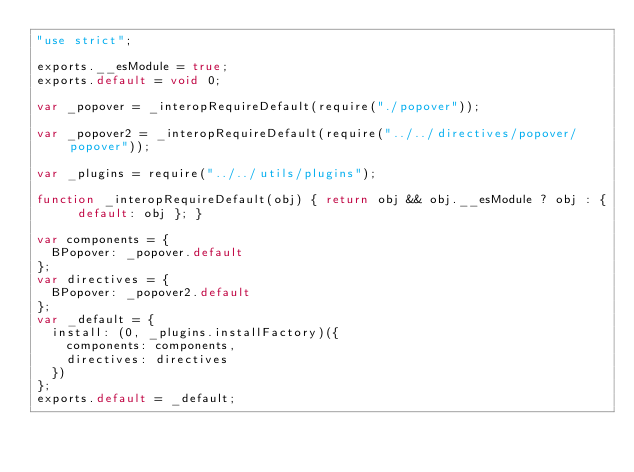Convert code to text. <code><loc_0><loc_0><loc_500><loc_500><_JavaScript_>"use strict";

exports.__esModule = true;
exports.default = void 0;

var _popover = _interopRequireDefault(require("./popover"));

var _popover2 = _interopRequireDefault(require("../../directives/popover/popover"));

var _plugins = require("../../utils/plugins");

function _interopRequireDefault(obj) { return obj && obj.__esModule ? obj : { default: obj }; }

var components = {
  BPopover: _popover.default
};
var directives = {
  BPopover: _popover2.default
};
var _default = {
  install: (0, _plugins.installFactory)({
    components: components,
    directives: directives
  })
};
exports.default = _default;</code> 